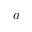Convert formula to latex. <formula><loc_0><loc_0><loc_500><loc_500>a</formula> 